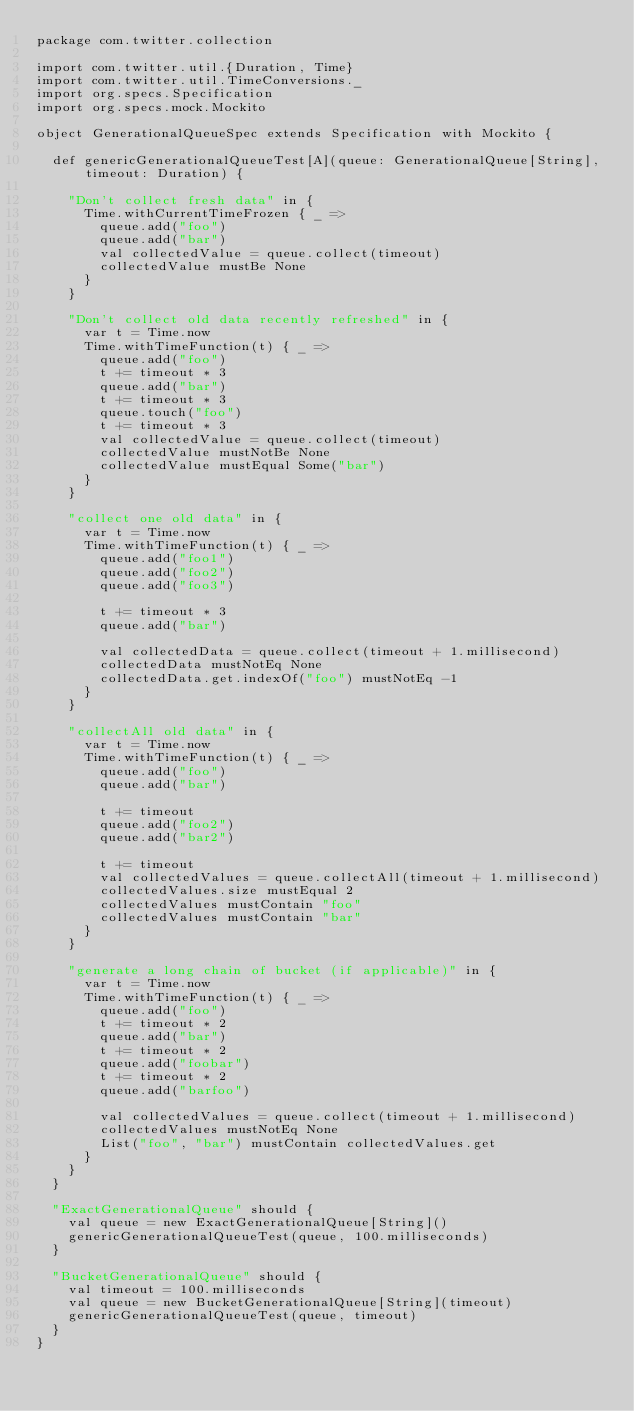Convert code to text. <code><loc_0><loc_0><loc_500><loc_500><_Scala_>package com.twitter.collection

import com.twitter.util.{Duration, Time}
import com.twitter.util.TimeConversions._
import org.specs.Specification
import org.specs.mock.Mockito

object GenerationalQueueSpec extends Specification with Mockito {

  def genericGenerationalQueueTest[A](queue: GenerationalQueue[String], timeout: Duration) {

    "Don't collect fresh data" in {
      Time.withCurrentTimeFrozen { _ =>
        queue.add("foo")
        queue.add("bar")
        val collectedValue = queue.collect(timeout)
        collectedValue mustBe None
      }
    }

    "Don't collect old data recently refreshed" in {
      var t = Time.now
      Time.withTimeFunction(t) { _ =>
        queue.add("foo")
        t += timeout * 3
        queue.add("bar")
        t += timeout * 3
        queue.touch("foo")
        t += timeout * 3
        val collectedValue = queue.collect(timeout)
        collectedValue mustNotBe None
        collectedValue mustEqual Some("bar")
      }
    }

    "collect one old data" in {
      var t = Time.now
      Time.withTimeFunction(t) { _ =>
        queue.add("foo1")
        queue.add("foo2")
        queue.add("foo3")

        t += timeout * 3
        queue.add("bar")

        val collectedData = queue.collect(timeout + 1.millisecond)
        collectedData mustNotEq None
        collectedData.get.indexOf("foo") mustNotEq -1
      }
    }

    "collectAll old data" in {
      var t = Time.now
      Time.withTimeFunction(t) { _ =>
        queue.add("foo")
        queue.add("bar")

        t += timeout
        queue.add("foo2")
        queue.add("bar2")

        t += timeout
        val collectedValues = queue.collectAll(timeout + 1.millisecond)
        collectedValues.size mustEqual 2
        collectedValues mustContain "foo"
        collectedValues mustContain "bar"
      }
    }

    "generate a long chain of bucket (if applicable)" in {
      var t = Time.now
      Time.withTimeFunction(t) { _ =>
        queue.add("foo")
        t += timeout * 2
        queue.add("bar")
        t += timeout * 2
        queue.add("foobar")
        t += timeout * 2
        queue.add("barfoo")

        val collectedValues = queue.collect(timeout + 1.millisecond)
        collectedValues mustNotEq None
        List("foo", "bar") mustContain collectedValues.get
      }
    }
  }

  "ExactGenerationalQueue" should {
    val queue = new ExactGenerationalQueue[String]()
    genericGenerationalQueueTest(queue, 100.milliseconds)
  }

  "BucketGenerationalQueue" should {
    val timeout = 100.milliseconds
    val queue = new BucketGenerationalQueue[String](timeout)
    genericGenerationalQueueTest(queue, timeout)
  }
}
</code> 